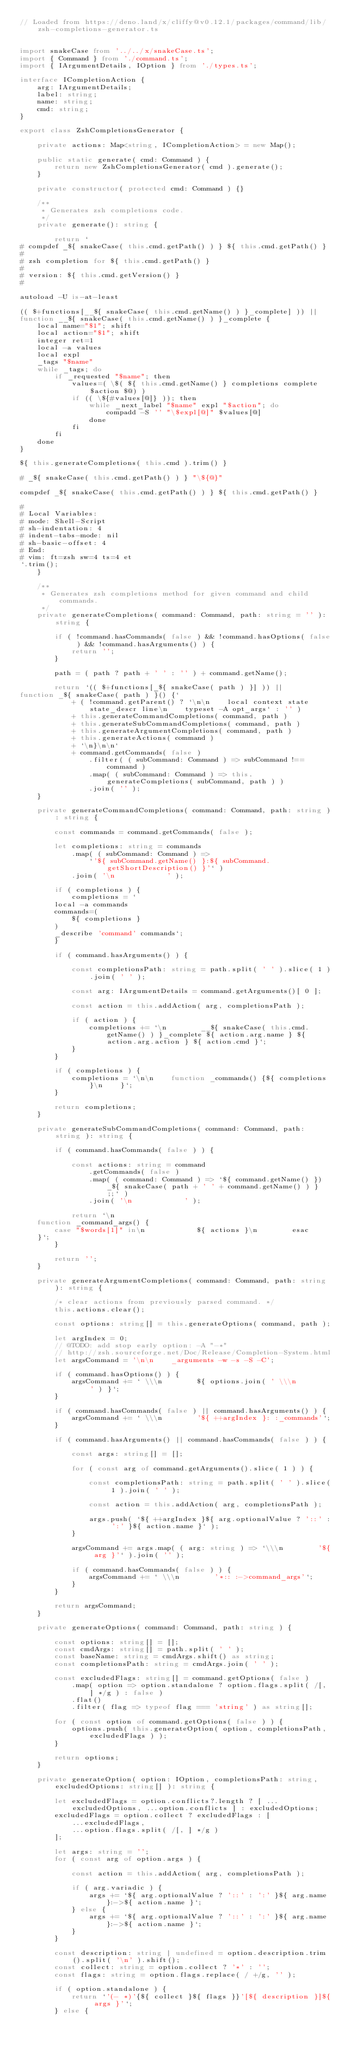<code> <loc_0><loc_0><loc_500><loc_500><_TypeScript_>// Loaded from https://deno.land/x/cliffy@v0.12.1/packages/command/lib/zsh-completions-generator.ts


import snakeCase from '../../x/snakeCase.ts';
import { Command } from './command.ts';
import { IArgumentDetails, IOption } from './types.ts';

interface ICompletionAction {
    arg: IArgumentDetails;
    label: string;
    name: string;
    cmd: string;
}

export class ZshCompletionsGenerator {

    private actions: Map<string, ICompletionAction> = new Map();

    public static generate( cmd: Command ) {
        return new ZshCompletionsGenerator( cmd ).generate();
    }

    private constructor( protected cmd: Command ) {}

    /**
     * Generates zsh completions code.
     */
    private generate(): string {

        return `
# compdef _${ snakeCase( this.cmd.getPath() ) } ${ this.cmd.getPath() }
#
# zsh completion for ${ this.cmd.getPath() }
#
# version: ${ this.cmd.getVersion() }
#

autoload -U is-at-least

(( $+functions[__${ snakeCase( this.cmd.getName() ) }_complete] )) ||
function __${ snakeCase( this.cmd.getName() ) }_complete {
    local name="$1"; shift
    local action="$1"; shift
    integer ret=1
    local -a values
    local expl
    _tags "$name"
    while _tags; do
        if _requested "$name"; then
            values=( \$( ${ this.cmd.getName() } completions complete $action $@) )
            if (( \${#values[@]} )); then
                while _next_label "$name" expl "$action"; do
                    compadd -S '' "\$expl[@]" $values[@]
                done
            fi
        fi
    done
}

${ this.generateCompletions( this.cmd ).trim() }

# _${ snakeCase( this.cmd.getPath() ) } "\${@}"

compdef _${ snakeCase( this.cmd.getPath() ) } ${ this.cmd.getPath() }

#
# Local Variables:
# mode: Shell-Script
# sh-indentation: 4
# indent-tabs-mode: nil
# sh-basic-offset: 4
# End:
# vim: ft=zsh sw=4 ts=4 et
`.trim();
    }

    /**
     * Generates zsh completions method for given command and child commands.
     */
    private generateCompletions( command: Command, path: string = '' ): string {

        if ( !command.hasCommands( false ) && !command.hasOptions( false ) && !command.hasArguments() ) {
            return '';
        }

        path = ( path ? path + ' ' : '' ) + command.getName();

        return `(( $+functions[_${ snakeCase( path ) }] )) ||
function _${ snakeCase( path ) }() {`
            + ( !command.getParent() ? `\n\n    local context state state_descr line\n    typeset -A opt_args` : '' )
            + this.generateCommandCompletions( command, path )
            + this.generateSubCommandCompletions( command, path )
            + this.generateArgumentCompletions( command, path )
            + this.generateActions( command )
            + `\n}\n\n`
            + command.getCommands( false )
                .filter( ( subCommand: Command ) => subCommand !== command )
                .map( ( subCommand: Command ) => this.generateCompletions( subCommand, path ) )
                .join( '' );
    }

    private generateCommandCompletions( command: Command, path: string ): string {

        const commands = command.getCommands( false );

        let completions: string = commands
            .map( ( subCommand: Command ) =>
                `'${ subCommand.getName() }:${ subCommand.getShortDescription() }'` )
            .join( '\n            ' );

        if ( completions ) {
            completions = `
        local -a commands
        commands=(
            ${ completions }
        )
        _describe 'command' commands`;
        }

        if ( command.hasArguments() ) {

            const completionsPath: string = path.split( ' ' ).slice( 1 ).join( ' ' );

            const arg: IArgumentDetails = command.getArguments()[ 0 ];

            const action = this.addAction( arg, completionsPath );

            if ( action ) {
                completions += `\n        __${ snakeCase( this.cmd.getName() ) }_complete ${ action.arg.name } ${ action.arg.action } ${ action.cmd }`;
            }
        }

        if ( completions ) {
            completions = `\n\n    function _commands() {${ completions }\n    }`;
        }

        return completions;
    }

    private generateSubCommandCompletions( command: Command, path: string ): string {

        if ( command.hasCommands( false ) ) {

            const actions: string = command
                .getCommands( false )
                .map( ( command: Command ) => `${ command.getName() }) _${ snakeCase( path + ' ' + command.getName() ) } ;;` )
                .join( '\n            ' );

            return `\n
    function _command_args() {
        case "$words[1]" in\n            ${ actions }\n        esac
    }`;
        }

        return '';
    }

    private generateArgumentCompletions( command: Command, path: string ): string {

        /* clear actions from previously parsed command. */
        this.actions.clear();

        const options: string[] = this.generateOptions( command, path );

        let argIndex = 0;
        // @TODO: add stop early option: -A "-*"
        // http://zsh.sourceforge.net/Doc/Release/Completion-System.html
        let argsCommand = '\n\n    _arguments -w -s -S -C';

        if ( command.hasOptions() ) {
            argsCommand += ` \\\n        ${ options.join( ' \\\n        ' ) }`;
        }

        if ( command.hasCommands( false ) || command.hasArguments() ) {
            argsCommand += ` \\\n        '${ ++argIndex }: :_commands'`;
        }

        if ( command.hasArguments() || command.hasCommands( false ) ) {

            const args: string[] = [];

            for ( const arg of command.getArguments().slice( 1 ) ) {

                const completionsPath: string = path.split( ' ' ).slice( 1 ).join( ' ' );

                const action = this.addAction( arg, completionsPath );

                args.push( `${ ++argIndex }${ arg.optionalValue ? '::' : ':' }${ action.name }` );
            }

            argsCommand += args.map( ( arg: string ) => `\\\n        '${ arg }'` ).join( '' );

            if ( command.hasCommands( false ) ) {
                argsCommand += ` \\\n        '*:: :->command_args'`;
            }
        }

        return argsCommand;
    }

    private generateOptions( command: Command, path: string ) {

        const options: string[] = [];
        const cmdArgs: string[] = path.split( ' ' );
        const baseName: string = cmdArgs.shift() as string;
        const completionsPath: string = cmdArgs.join( ' ' );

        const excludedFlags: string[] = command.getOptions( false )
            .map( option => option.standalone ? option.flags.split( /[, ] */g ) : false )
            .flat()
            .filter( flag => typeof flag === 'string' ) as string[];

        for ( const option of command.getOptions( false ) ) {
            options.push( this.generateOption( option, completionsPath, excludedFlags ) );
        }

        return options;
    }

    private generateOption( option: IOption, completionsPath: string, excludedOptions: string[] ): string {

        let excludedFlags = option.conflicts?.length ? [ ...excludedOptions, ...option.conflicts ] : excludedOptions;
        excludedFlags = option.collect ? excludedFlags : [
            ...excludedFlags,
            ...option.flags.split( /[, ] */g )
        ];

        let args: string = '';
        for ( const arg of option.args ) {

            const action = this.addAction( arg, completionsPath );

            if ( arg.variadic ) {
                args += `${ arg.optionalValue ? '::' : ':' }${ arg.name }:->${ action.name }`;
            } else {
                args += `${ arg.optionalValue ? '::' : ':' }${ arg.name }:->${ action.name }`;
            }
        }

        const description: string | undefined = option.description.trim().split( '\n' ).shift();
        const collect: string = option.collect ? '*' : '';
        const flags: string = option.flags.replace( / +/g, '' );

        if ( option.standalone ) {
            return `'(- *)'{${ collect }${ flags }}'[${ description }]${ args }'`;
        } else {</code> 